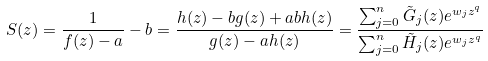Convert formula to latex. <formula><loc_0><loc_0><loc_500><loc_500>S ( z ) = \frac { 1 } { f ( z ) - a } - b = \frac { h ( z ) - b g ( z ) + a b h ( z ) } { g ( z ) - a h ( z ) } = \frac { \sum _ { j = 0 } ^ { n } \tilde { G } _ { j } ( z ) e ^ { w _ { j } z ^ { q } } } { \sum _ { j = 0 } ^ { n } \tilde { H } _ { j } ( z ) e ^ { w _ { j } z ^ { q } } }</formula> 